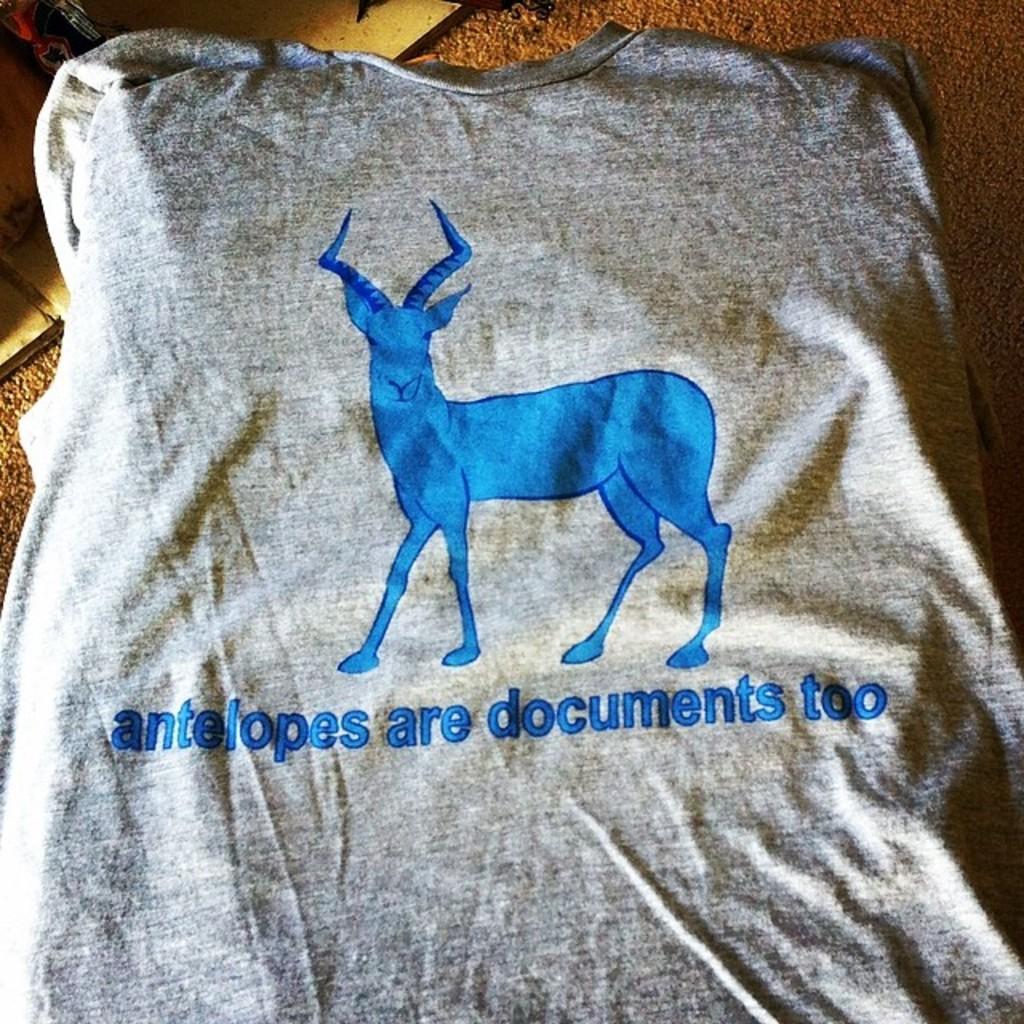Can you describe this image briefly? Picture of an animal on this t-shirt. 